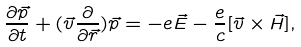<formula> <loc_0><loc_0><loc_500><loc_500>\frac { \partial { \vec { p } } } { \partial { t } } + ( \vec { v } \frac { \partial } { \partial \vec { r } } ) \vec { p } = - e \vec { E } - \frac { e } { c } [ \vec { v } \times \vec { H } ] ,</formula> 